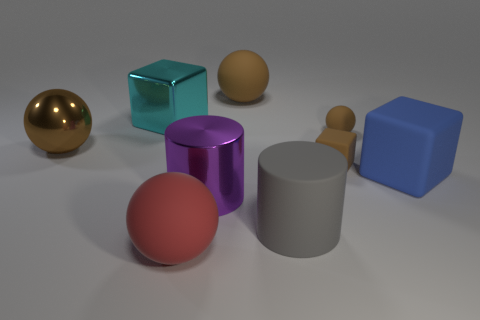Subtract all big metal balls. How many balls are left? 3 Subtract all red balls. How many balls are left? 3 Add 1 gray rubber spheres. How many objects exist? 10 Add 2 big blue matte objects. How many big blue matte objects are left? 3 Add 9 yellow shiny things. How many yellow shiny things exist? 9 Subtract 1 blue blocks. How many objects are left? 8 Subtract all cylinders. How many objects are left? 7 Subtract 1 balls. How many balls are left? 3 Subtract all purple spheres. Subtract all purple cylinders. How many spheres are left? 4 Subtract all blue cylinders. How many gray spheres are left? 0 